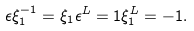Convert formula to latex. <formula><loc_0><loc_0><loc_500><loc_500>\epsilon \xi _ { 1 } ^ { - 1 } = \xi _ { 1 } \epsilon ^ { L } = 1 \xi _ { 1 } ^ { L } = - 1 .</formula> 